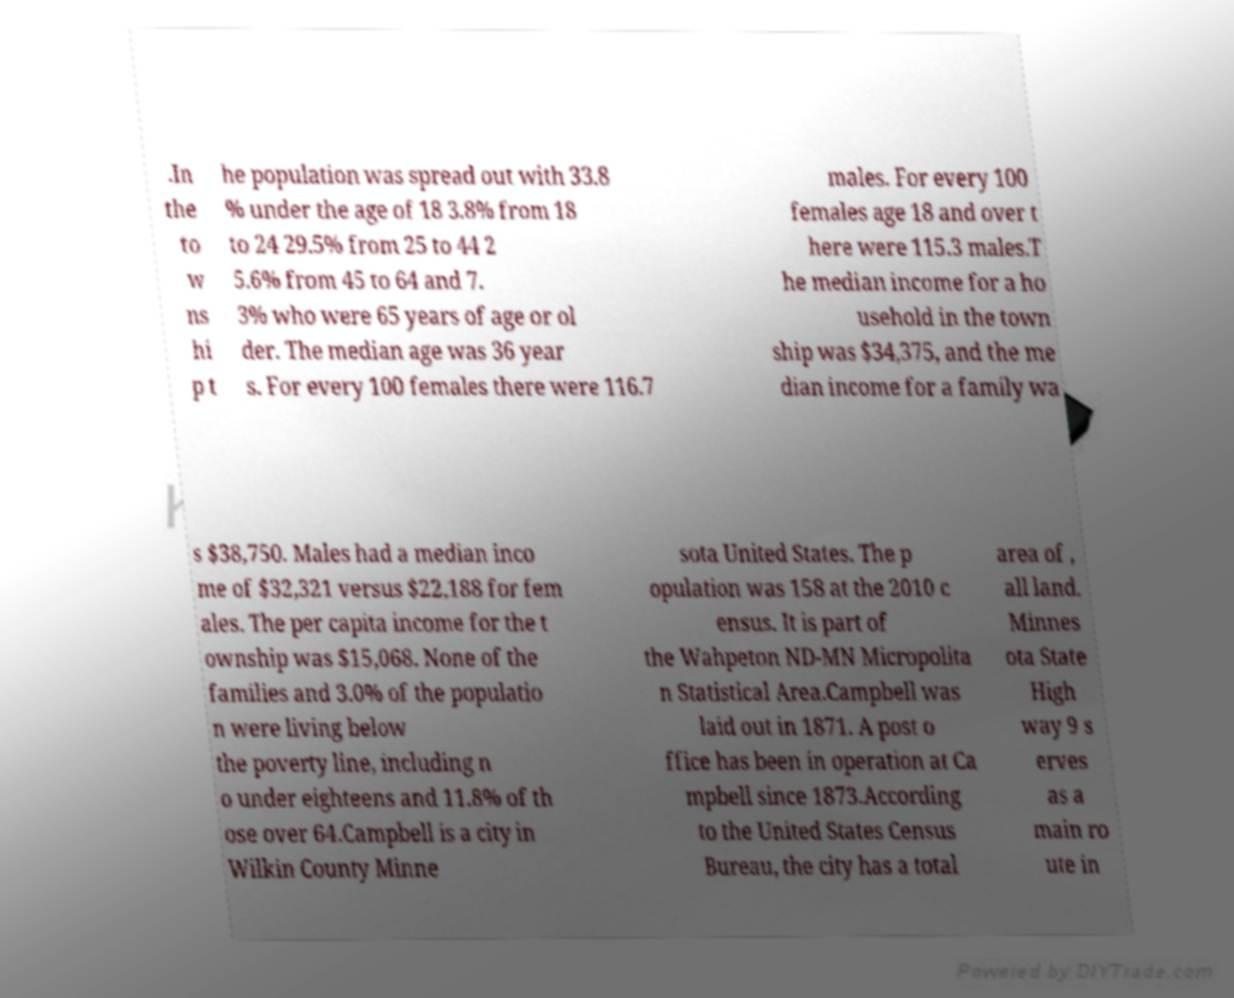What messages or text are displayed in this image? I need them in a readable, typed format. .In the to w ns hi p t he population was spread out with 33.8 % under the age of 18 3.8% from 18 to 24 29.5% from 25 to 44 2 5.6% from 45 to 64 and 7. 3% who were 65 years of age or ol der. The median age was 36 year s. For every 100 females there were 116.7 males. For every 100 females age 18 and over t here were 115.3 males.T he median income for a ho usehold in the town ship was $34,375, and the me dian income for a family wa s $38,750. Males had a median inco me of $32,321 versus $22,188 for fem ales. The per capita income for the t ownship was $15,068. None of the families and 3.0% of the populatio n were living below the poverty line, including n o under eighteens and 11.8% of th ose over 64.Campbell is a city in Wilkin County Minne sota United States. The p opulation was 158 at the 2010 c ensus. It is part of the Wahpeton ND-MN Micropolita n Statistical Area.Campbell was laid out in 1871. A post o ffice has been in operation at Ca mpbell since 1873.According to the United States Census Bureau, the city has a total area of , all land. Minnes ota State High way 9 s erves as a main ro ute in 